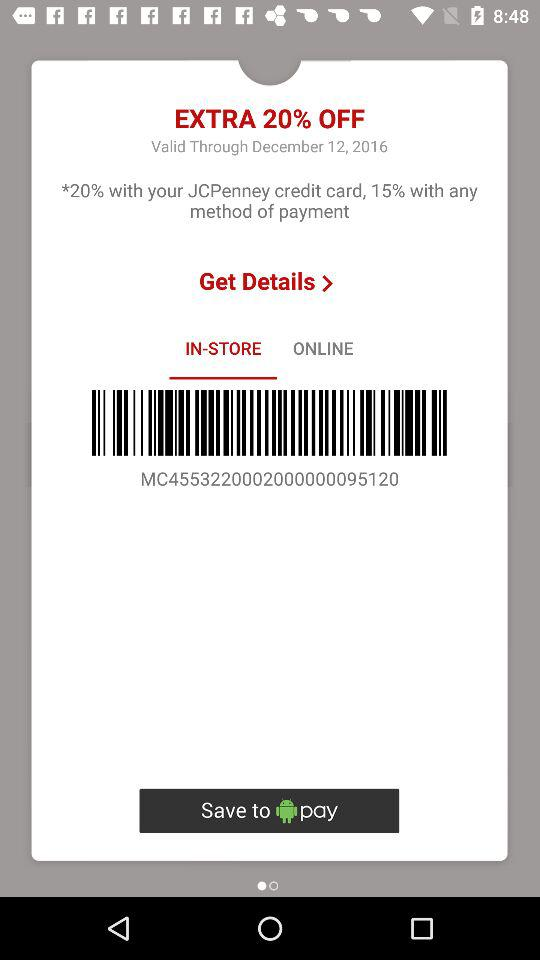How much discount is on the JCPenney credit card? The JCPenney credit card offers a discount of 20%. 